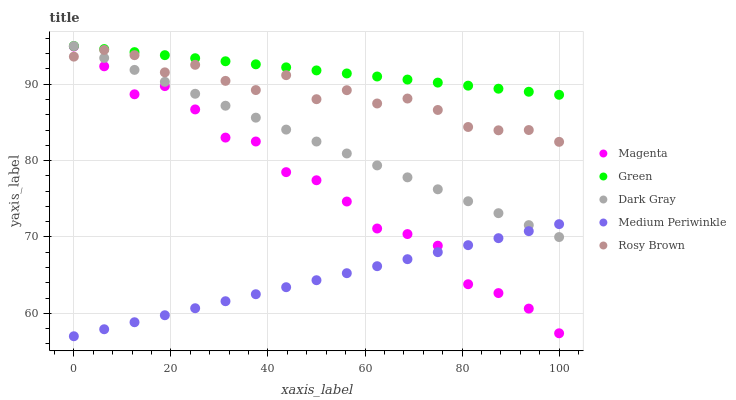Does Medium Periwinkle have the minimum area under the curve?
Answer yes or no. Yes. Does Green have the maximum area under the curve?
Answer yes or no. Yes. Does Magenta have the minimum area under the curve?
Answer yes or no. No. Does Magenta have the maximum area under the curve?
Answer yes or no. No. Is Medium Periwinkle the smoothest?
Answer yes or no. Yes. Is Magenta the roughest?
Answer yes or no. Yes. Is Magenta the smoothest?
Answer yes or no. No. Is Medium Periwinkle the roughest?
Answer yes or no. No. Does Medium Periwinkle have the lowest value?
Answer yes or no. Yes. Does Magenta have the lowest value?
Answer yes or no. No. Does Green have the highest value?
Answer yes or no. Yes. Does Magenta have the highest value?
Answer yes or no. No. Is Magenta less than Dark Gray?
Answer yes or no. Yes. Is Green greater than Medium Periwinkle?
Answer yes or no. Yes. Does Dark Gray intersect Rosy Brown?
Answer yes or no. Yes. Is Dark Gray less than Rosy Brown?
Answer yes or no. No. Is Dark Gray greater than Rosy Brown?
Answer yes or no. No. Does Magenta intersect Dark Gray?
Answer yes or no. No. 